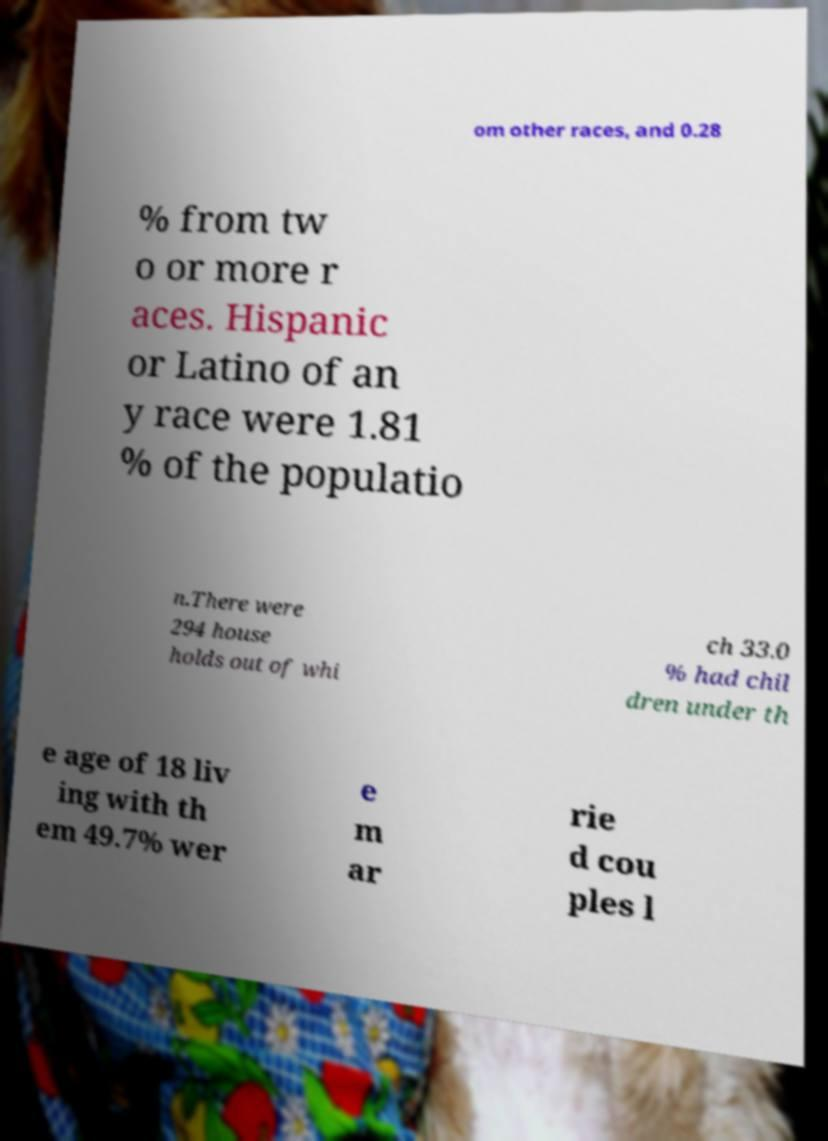I need the written content from this picture converted into text. Can you do that? om other races, and 0.28 % from tw o or more r aces. Hispanic or Latino of an y race were 1.81 % of the populatio n.There were 294 house holds out of whi ch 33.0 % had chil dren under th e age of 18 liv ing with th em 49.7% wer e m ar rie d cou ples l 